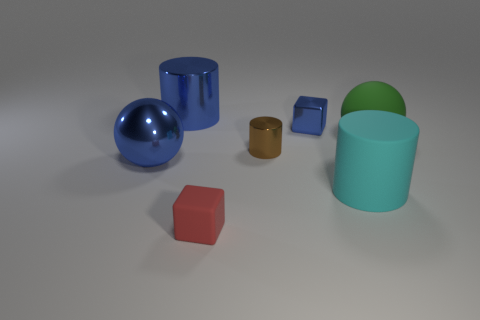Subtract all large cylinders. How many cylinders are left? 1 Add 3 purple cubes. How many objects exist? 10 Subtract 1 cylinders. How many cylinders are left? 2 Subtract all cylinders. How many objects are left? 4 Subtract 1 cyan cylinders. How many objects are left? 6 Subtract all yellow balls. Subtract all brown blocks. How many balls are left? 2 Subtract all small red blocks. Subtract all small yellow rubber cubes. How many objects are left? 6 Add 4 brown things. How many brown things are left? 5 Add 1 large blue cylinders. How many large blue cylinders exist? 2 